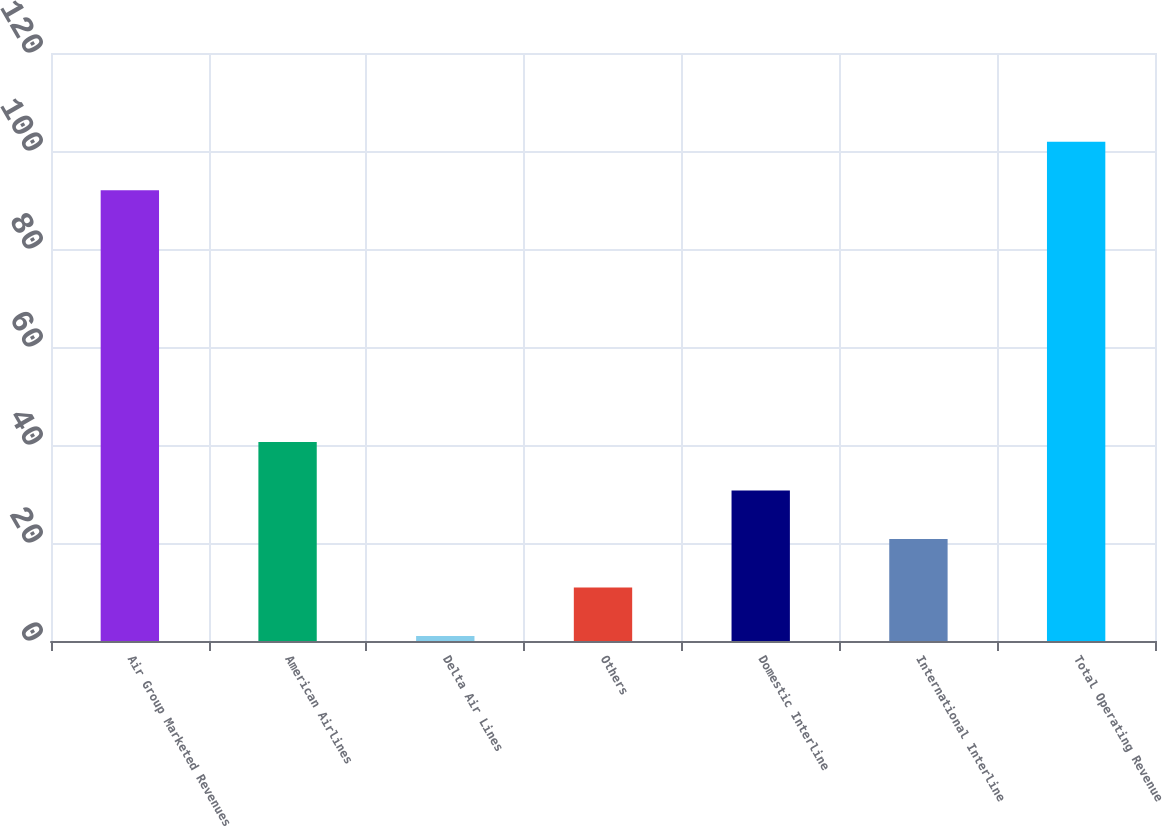Convert chart. <chart><loc_0><loc_0><loc_500><loc_500><bar_chart><fcel>Air Group Marketed Revenues<fcel>American Airlines<fcel>Delta Air Lines<fcel>Others<fcel>Domestic Interline<fcel>International Interline<fcel>Total Operating Revenue<nl><fcel>92<fcel>40.6<fcel>1<fcel>10.9<fcel>30.7<fcel>20.8<fcel>101.9<nl></chart> 